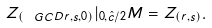Convert formula to latex. <formula><loc_0><loc_0><loc_500><loc_500>Z _ { ( \ G C D { r , s } , 0 ) } | _ { 0 , \hat { c } / 2 } M = Z _ { ( r , s ) } .</formula> 